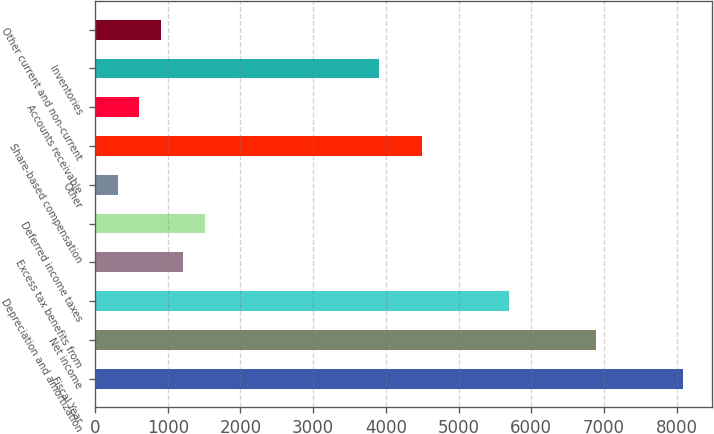<chart> <loc_0><loc_0><loc_500><loc_500><bar_chart><fcel>Fiscal Year<fcel>Net income<fcel>Depreciation and amortization<fcel>Excess tax benefits from<fcel>Deferred income taxes<fcel>Other<fcel>Share-based compensation<fcel>Accounts receivable<fcel>Inventories<fcel>Other current and non-current<nl><fcel>8085<fcel>6889<fcel>5693<fcel>1208<fcel>1507<fcel>311<fcel>4497<fcel>610<fcel>3899<fcel>909<nl></chart> 